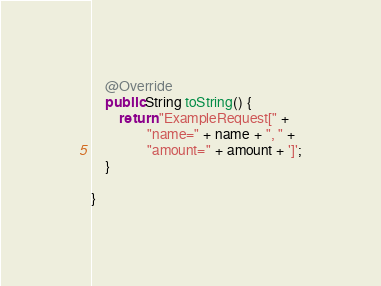<code> <loc_0><loc_0><loc_500><loc_500><_Java_>    @Override
    public String toString() {
        return "ExampleRequest[" +
                "name=" + name + ", " +
                "amount=" + amount + ']';
    }

}
</code> 